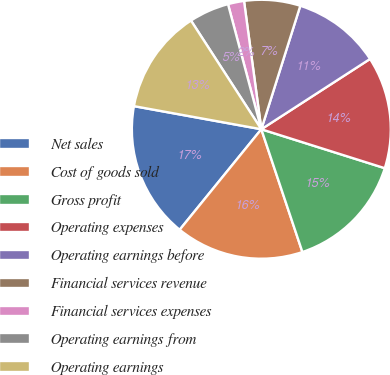<chart> <loc_0><loc_0><loc_500><loc_500><pie_chart><fcel>Net sales<fcel>Cost of goods sold<fcel>Gross profit<fcel>Operating expenses<fcel>Operating earnings before<fcel>Financial services revenue<fcel>Financial services expenses<fcel>Operating earnings from<fcel>Operating earnings<nl><fcel>17.0%<fcel>16.0%<fcel>15.0%<fcel>14.0%<fcel>11.0%<fcel>7.0%<fcel>2.01%<fcel>5.0%<fcel>13.0%<nl></chart> 